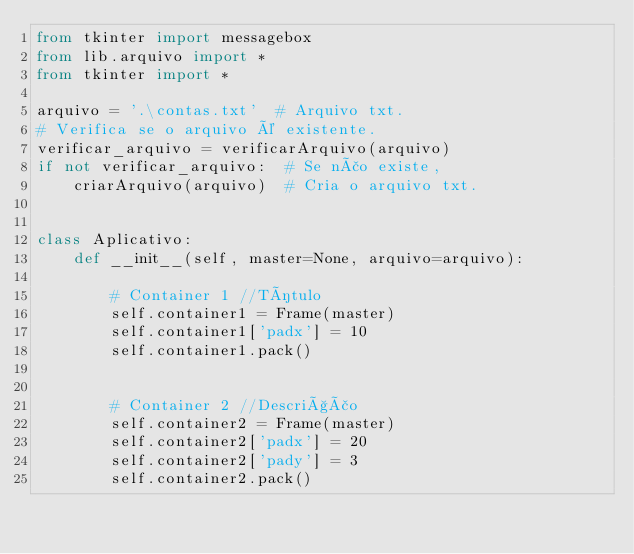Convert code to text. <code><loc_0><loc_0><loc_500><loc_500><_Python_>from tkinter import messagebox
from lib.arquivo import *
from tkinter import *

arquivo = '.\contas.txt'  # Arquivo txt.
# Verifica se o arquivo é existente.
verificar_arquivo = verificarArquivo(arquivo)
if not verificar_arquivo:  # Se não existe,
    criarArquivo(arquivo)  # Cria o arquivo txt.


class Aplicativo:
    def __init__(self, master=None, arquivo=arquivo):

        # Container 1 //Título
        self.container1 = Frame(master)
        self.container1['padx'] = 10
        self.container1.pack()
        

        # Container 2 //Descrição
        self.container2 = Frame(master)
        self.container2['padx'] = 20
        self.container2['pady'] = 3
        self.container2.pack()
</code> 